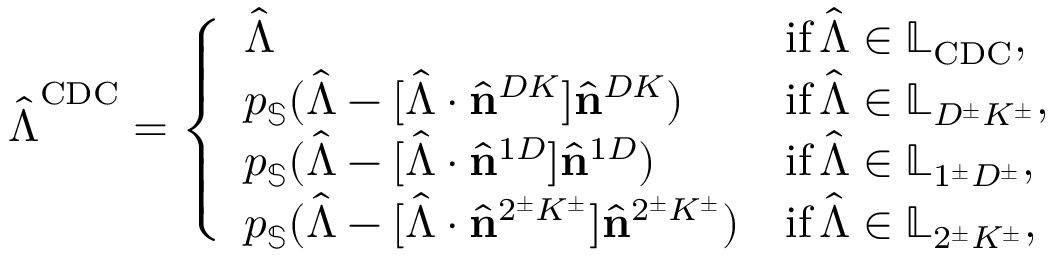<formula> <loc_0><loc_0><loc_500><loc_500>\hat { \Lambda } ^ { C D C } = \left \{ \begin{array} { l l } { \hat { \Lambda } } & { i f \, \hat { \Lambda } \in \mathbb { L } _ { C D C } , } \\ { p _ { \mathbb { S } } ( \hat { \Lambda } - [ \hat { \Lambda } \cdot \hat { n } ^ { D K } ] \hat { n } ^ { D K } ) } & { i f \, \hat { \Lambda } \in \mathbb { L } _ { D ^ { \pm } K ^ { \pm } } , } \\ { p _ { \mathbb { S } } ( \hat { \Lambda } - [ \hat { \Lambda } \cdot \hat { n } ^ { 1 D } ] \hat { n } ^ { 1 D } ) } & { i f \, \hat { \Lambda } \in \mathbb { L } _ { 1 ^ { \pm } D ^ { \pm } } , } \\ { p _ { \mathbb { S } } ( \hat { \Lambda } - [ \hat { \Lambda } \cdot \hat { n } ^ { 2 ^ { \pm } K ^ { \pm } } ] \hat { n } ^ { 2 ^ { \pm } K ^ { \pm } } ) } & { i f \, \hat { \Lambda } \in \mathbb { L } _ { 2 ^ { \pm } K ^ { \pm } } , } \end{array}</formula> 